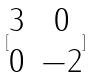<formula> <loc_0><loc_0><loc_500><loc_500>[ \begin{matrix} 3 & 0 \\ 0 & - 2 \end{matrix} ]</formula> 